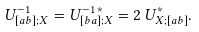Convert formula to latex. <formula><loc_0><loc_0><loc_500><loc_500>U ^ { - 1 } _ { [ a b ] ; X } = U ^ { - 1 \, * } _ { [ b a ] ; X } = 2 \, U ^ { * } _ { X ; [ a b ] } .</formula> 